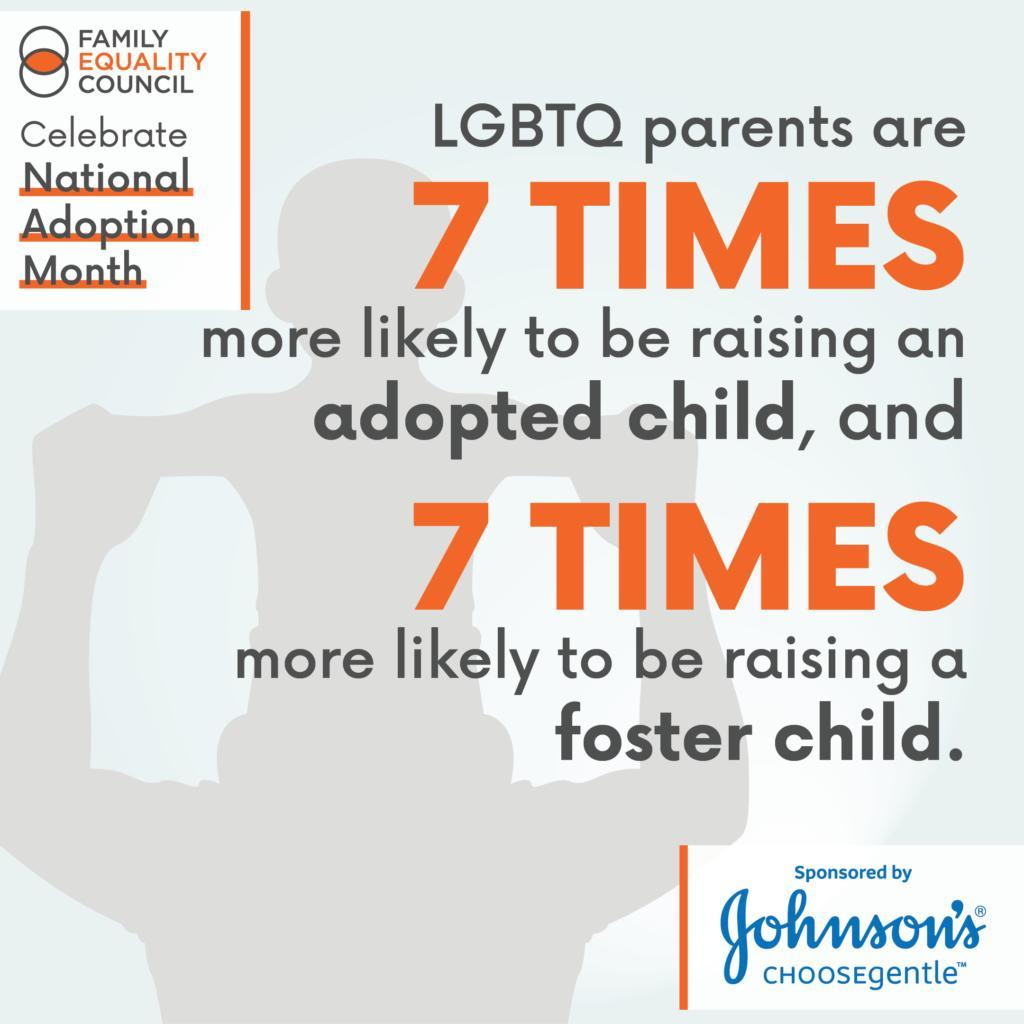what is being celebrated
Answer the question with a short phrase. National Adoption Month who is more likely to raise a foster child LGBTQ parents what is the colour of digit 7 , orange or blue orange 